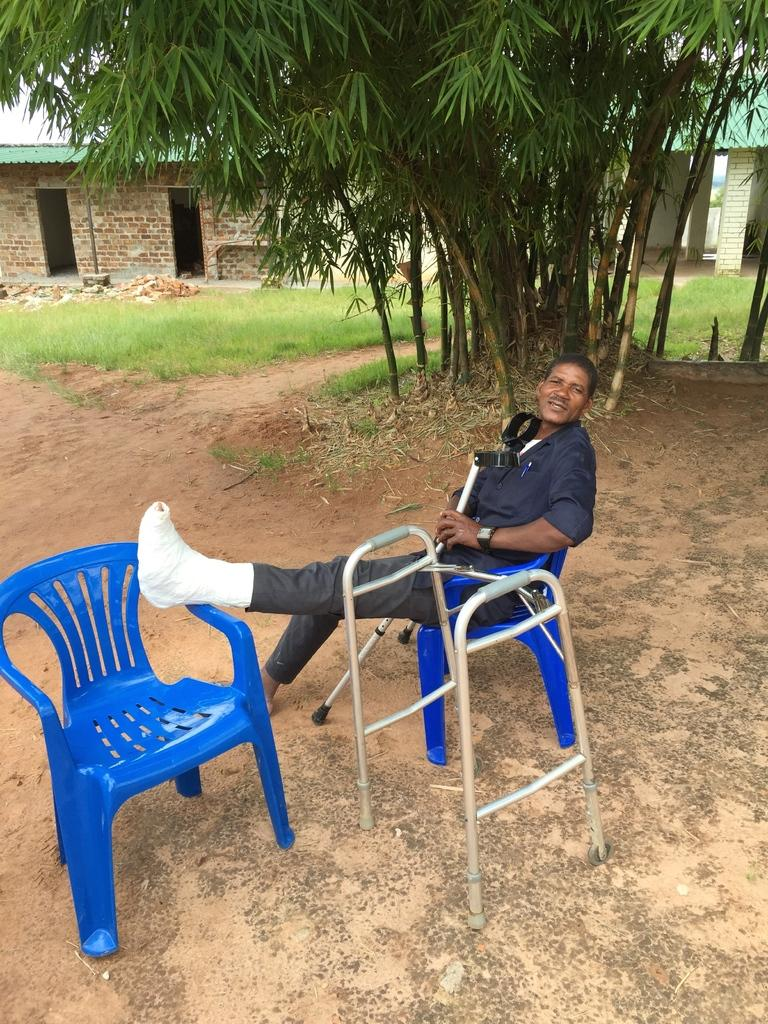What is the man in the image doing? The man is sitting in the image. What is the man holding in the image? The man is holding a stick in the image. What can be seen in the image besides the man? There is a stand, chairs, trees, sheds, and grass in the background of the image. Can you tell me how many times the man kicks the grass in the image? There is no indication in the image that the man is kicking the grass, so it cannot be determined from the picture. 